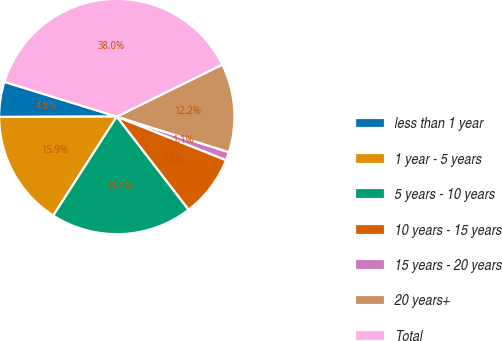Convert chart to OTSL. <chart><loc_0><loc_0><loc_500><loc_500><pie_chart><fcel>less than 1 year<fcel>1 year - 5 years<fcel>5 years - 10 years<fcel>10 years - 15 years<fcel>15 years - 20 years<fcel>20 years+<fcel>Total<nl><fcel>4.82%<fcel>15.86%<fcel>19.54%<fcel>8.5%<fcel>1.14%<fcel>12.18%<fcel>37.95%<nl></chart> 